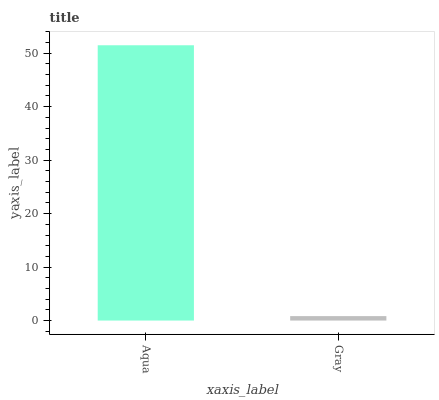Is Gray the maximum?
Answer yes or no. No. Is Aqua greater than Gray?
Answer yes or no. Yes. Is Gray less than Aqua?
Answer yes or no. Yes. Is Gray greater than Aqua?
Answer yes or no. No. Is Aqua less than Gray?
Answer yes or no. No. Is Aqua the high median?
Answer yes or no. Yes. Is Gray the low median?
Answer yes or no. Yes. Is Gray the high median?
Answer yes or no. No. Is Aqua the low median?
Answer yes or no. No. 